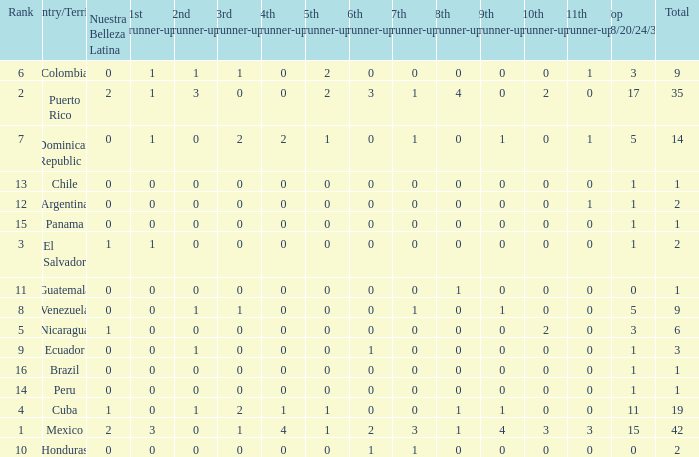What is the lowest 7th runner-up of the country with a top 18/20/24/30 greater than 5, a 1st runner-up greater than 0, and an 11th runner-up less than 0? None. Could you parse the entire table as a dict? {'header': ['Rank', 'Country/Territory', 'Nuestra Belleza Latina', '1st runner-up', '2nd runner-up', '3rd runner-up', '4th runner-up', '5th runner-up', '6th runner-up', '7th runner-up', '8th runner-up', '9th runner-up', '10th runner-up', '11th runner-up', 'Top 18/20/24/30', 'Total'], 'rows': [['6', 'Colombia', '0', '1', '1', '1', '0', '2', '0', '0', '0', '0', '0', '1', '3', '9'], ['2', 'Puerto Rico', '2', '1', '3', '0', '0', '2', '3', '1', '4', '0', '2', '0', '17', '35'], ['7', 'Dominican Republic', '0', '1', '0', '2', '2', '1', '0', '1', '0', '1', '0', '1', '5', '14'], ['13', 'Chile', '0', '0', '0', '0', '0', '0', '0', '0', '0', '0', '0', '0', '1', '1'], ['12', 'Argentina', '0', '0', '0', '0', '0', '0', '0', '0', '0', '0', '0', '1', '1', '2'], ['15', 'Panama', '0', '0', '0', '0', '0', '0', '0', '0', '0', '0', '0', '0', '1', '1'], ['3', 'El Salvador', '1', '1', '0', '0', '0', '0', '0', '0', '0', '0', '0', '0', '1', '2'], ['11', 'Guatemala', '0', '0', '0', '0', '0', '0', '0', '0', '1', '0', '0', '0', '0', '1'], ['8', 'Venezuela', '0', '0', '1', '1', '0', '0', '0', '1', '0', '1', '0', '0', '5', '9'], ['5', 'Nicaragua', '1', '0', '0', '0', '0', '0', '0', '0', '0', '0', '2', '0', '3', '6'], ['9', 'Ecuador', '0', '0', '1', '0', '0', '0', '1', '0', '0', '0', '0', '0', '1', '3'], ['16', 'Brazil', '0', '0', '0', '0', '0', '0', '0', '0', '0', '0', '0', '0', '1', '1'], ['14', 'Peru', '0', '0', '0', '0', '0', '0', '0', '0', '0', '0', '0', '0', '1', '1'], ['4', 'Cuba', '1', '0', '1', '2', '1', '1', '0', '0', '1', '1', '0', '0', '11', '19'], ['1', 'Mexico', '2', '3', '0', '1', '4', '1', '2', '3', '1', '4', '3', '3', '15', '42'], ['10', 'Honduras', '0', '0', '0', '0', '0', '0', '1', '1', '0', '0', '0', '0', '0', '2']]} 